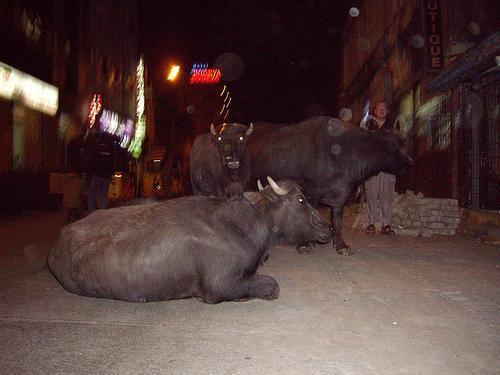How many bulls?
Give a very brief answer. 3. 